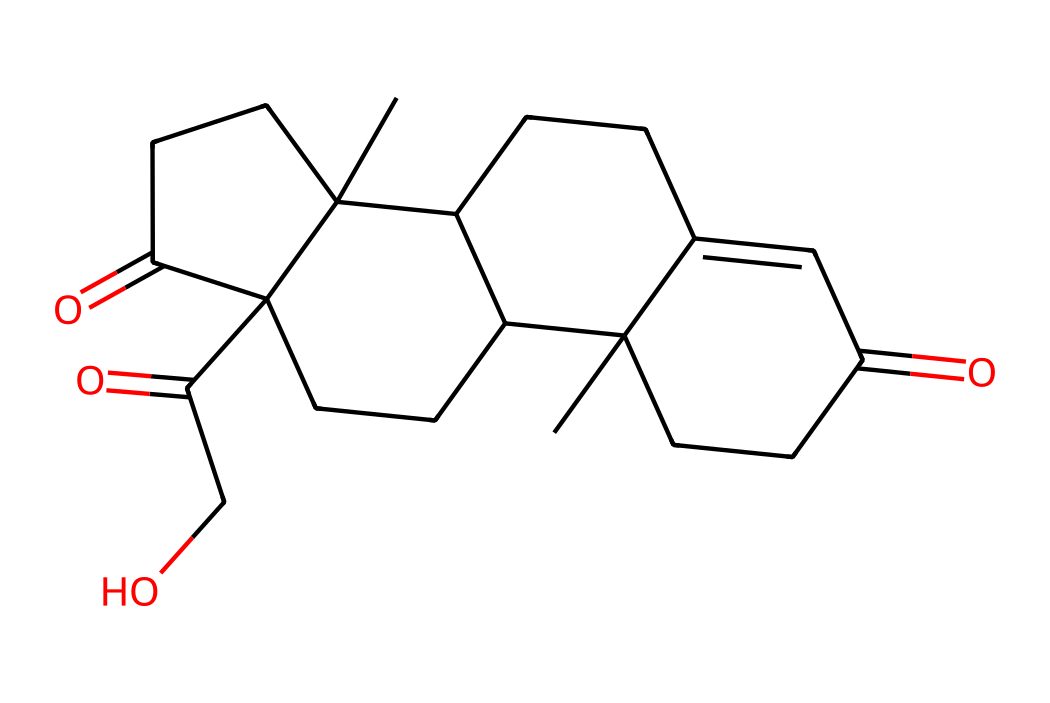What is the molecular formula of cortisol? To determine the molecular formula, one needs to count the different atoms present in the SMILES representation: there are 21 carbon (C) atoms, 30 hydrogen (H) atoms, and 5 oxygen (O) atoms, which combines to form C21H30O5.
Answer: C21H30O5 How many rings are present in the chemical structure of cortisol? Analyzing the SMILES notation, the structure contains a total of four rings, inferred from the presence of the numbers in the SMILES which indicate bonds forming cyclic structures.
Answer: 4 What type of functional groups does cortisol possess? In the structure of cortisol, the two carbonyl groups (C=O) and one hydroxyl group (–OH) are identified as major functional groups, indicating it possesses ketones and alcohol functionalities.
Answer: ketone and alcohol What is the significance of the hydroxyl group in cortisol? The presence of the hydroxyl group (–OH) in the cortisol structure is crucial as it contributes to the molecule's ability to participate in hydrogen bonding, influencing its solubility and biological activity.
Answer: solubility and biological activity Is cortisol classified as a steroid hormone? Cortisol’s chemical structure, characterized by its tetracyclic architecture similar to that of steroids, aligns with the classification of steroid hormones due to its origin and function in regulating various physiological processes.
Answer: yes 